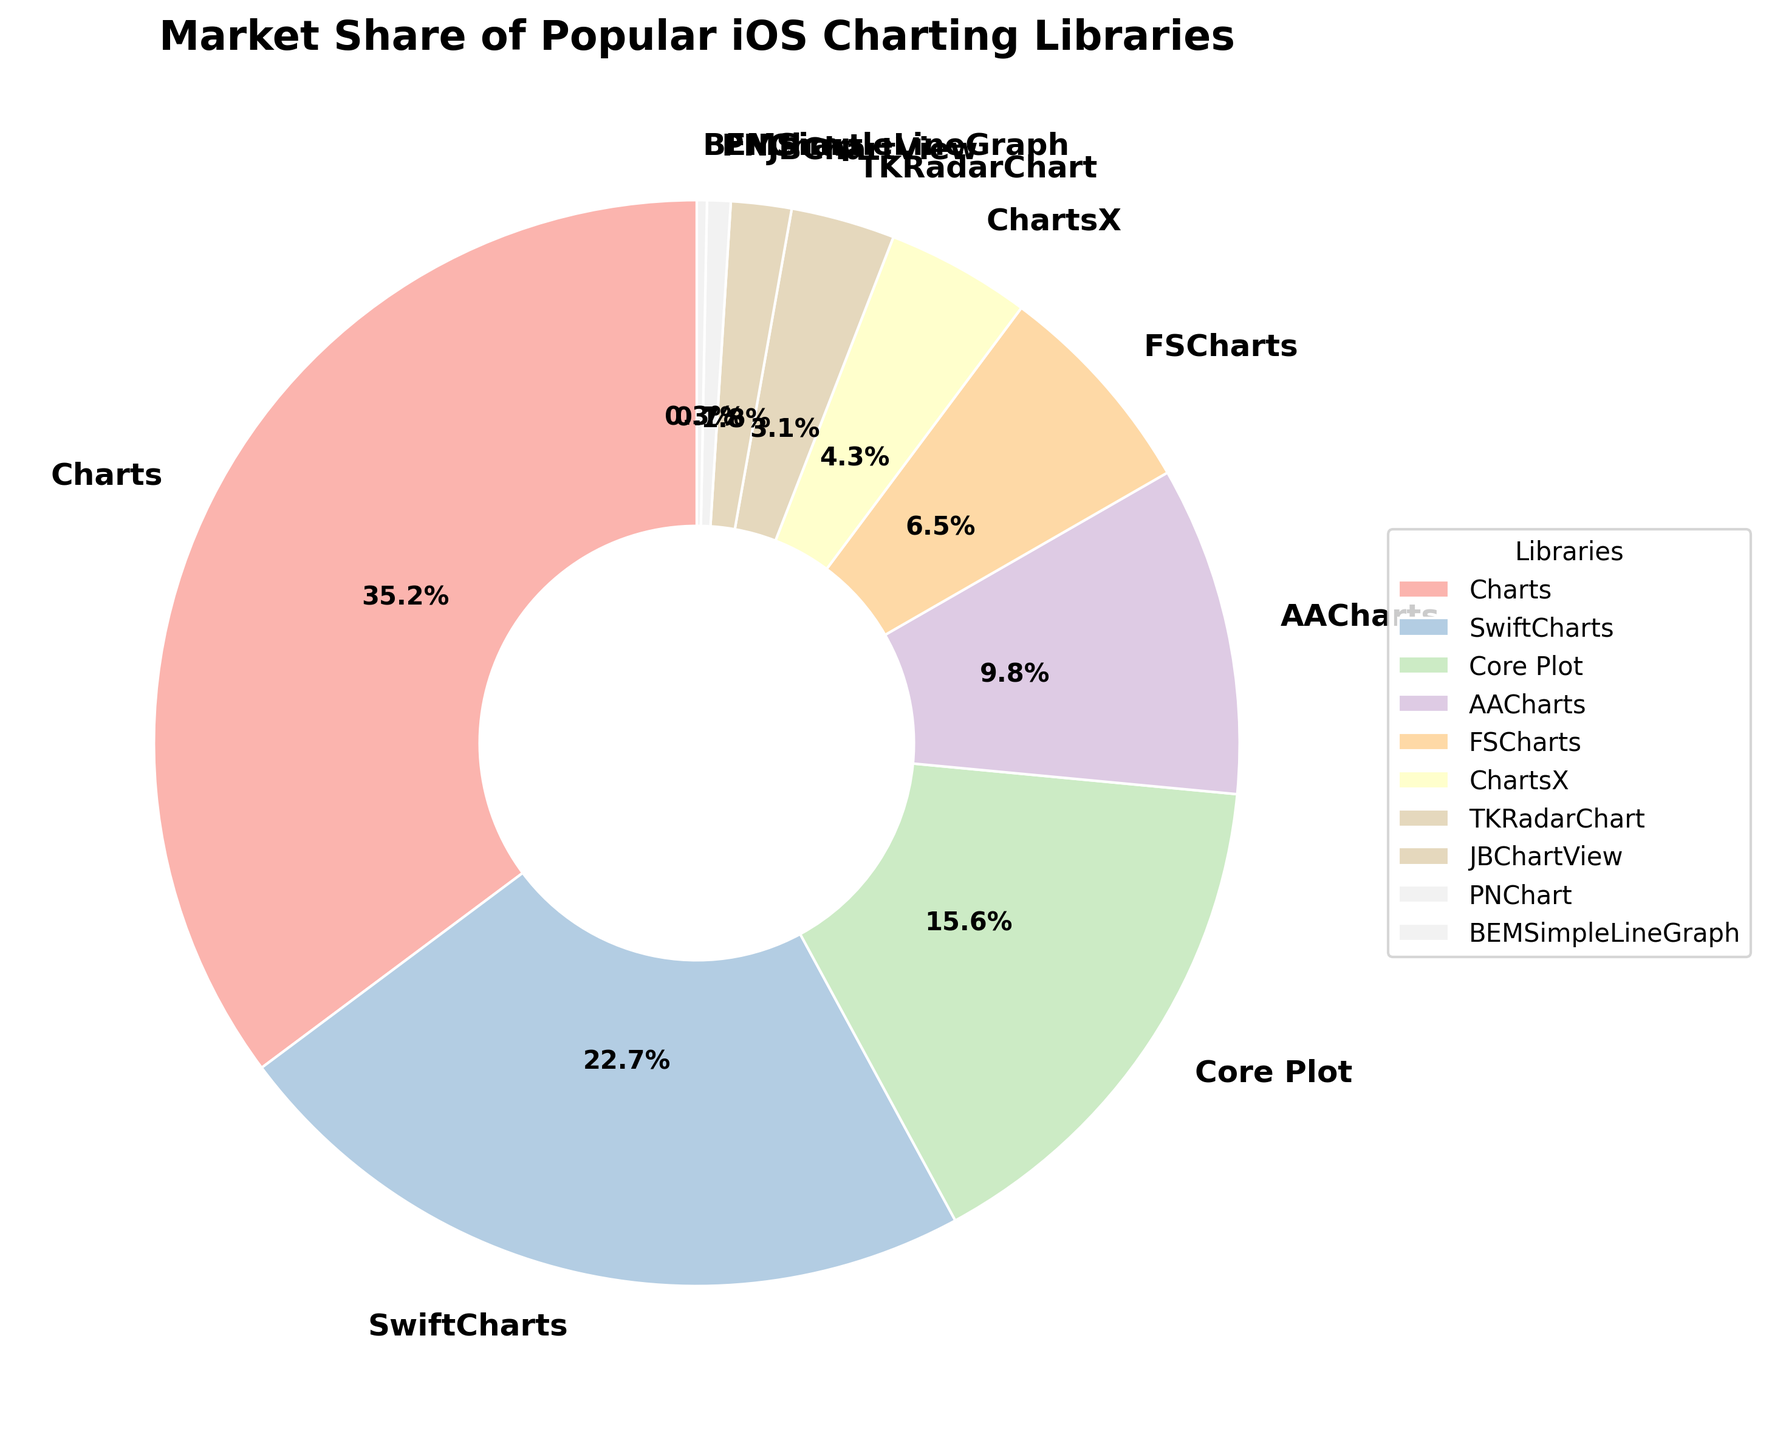Which library has the largest market share? The figure shows different libraries and their market shares. By looking at the slices and the corresponding percentages, we can see which library has the largest value.
Answer: Charts What is the market share difference between Charts and SwiftCharts? The market share for Charts is 35.2%, and for SwiftCharts, it is 22.7%. Subtract the smaller percentage from the larger one: 35.2 - 22.7 = 12.5%
Answer: 12.5% Which libraries have a market share of less than 5%? By examining the pie chart and the percentages shown, we see that ChartsX, TKRadarChart, JBChartView, PNChart, and BEMSimpleLineGraph each have market shares of less than 5%.
Answer: ChartsX, TKRadarChart, JBChartView, PNChart, BEMSimpleLineGraph What is the combined market share of Core Plot, AACharts, and FSCharts? The market shares for Core Plot, AACharts, and FSCharts are 15.6%, 9.8%, and 6.5% respectively. Summing these up: 15.6 + 9.8 + 6.5 = 31.9%
Answer: 31.9% Which library has the smallest market share, and what is that share? By looking at the slices and their percentages, BEMSimpleLineGraph has the smallest slice. The percentage shown for it is 0.3%.
Answer: BEMSimpleLineGraph, 0.3% How many libraries have a market share between 1% and 10% inclusive? The libraries with market shares within this range are AACharts, FSCharts, ChartsX, TKRadarChart, JBChartView, and PNChart. Counting these gives us 6 libraries.
Answer: 6 What is the approximate color of the slice representing SwiftCharts? By looking at the legend and corresponding slice, SwiftCharts is represented in a pastel color scheme, specifically a light green shade.
Answer: Light green Is the sum of the market shares of the bottom three libraries larger than the market share of AACharts? The market shares of the bottom three libraries (PNChart, JBChartView, BEMSimpleLineGraph) are 0.7%, 1.8%, and 0.3% respectively. Summing these gives 0.7 + 1.8 + 0.3 = 2.8%. This is less than the market share of AACharts which is 9.8%.
Answer: No 